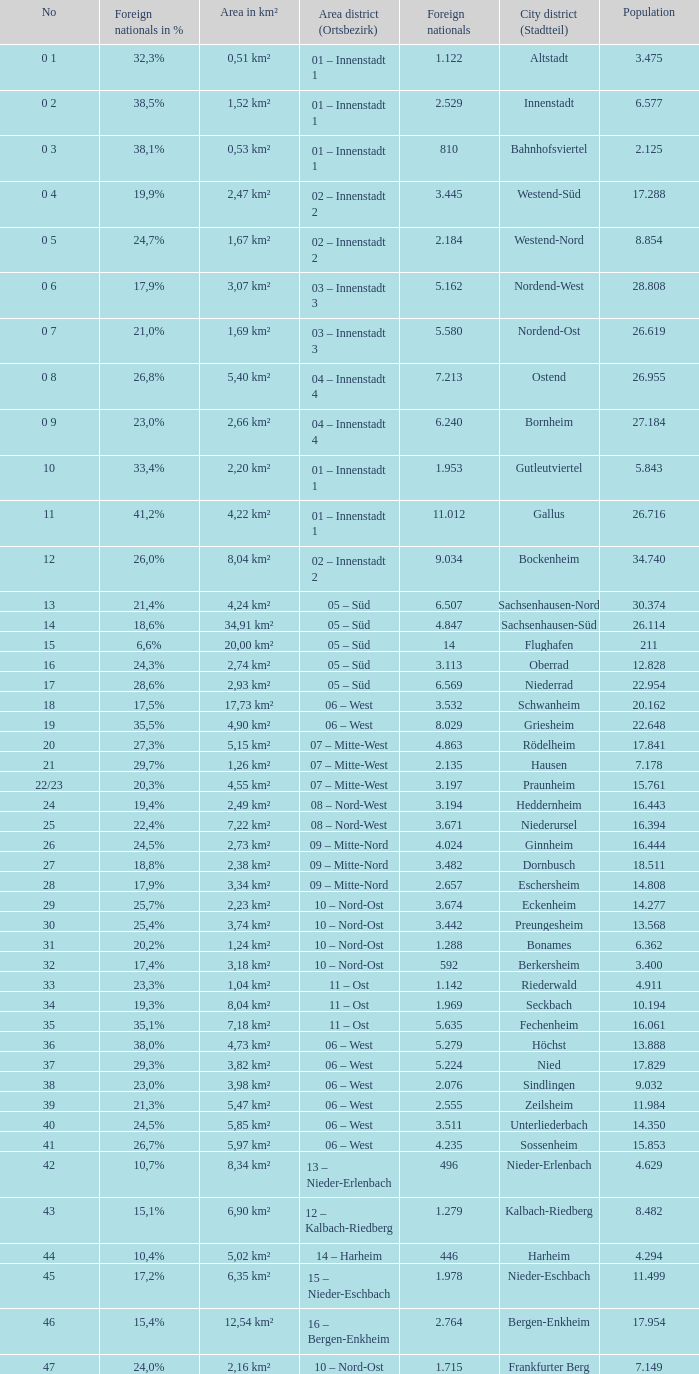What is the number of the city district of stadtteil where foreigners are 5.162? 1.0. 